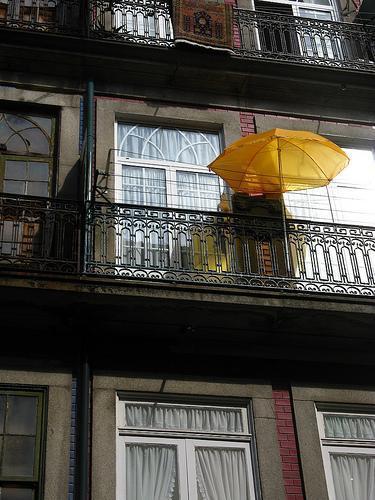How many umbrellas are visible?
Give a very brief answer. 1. 